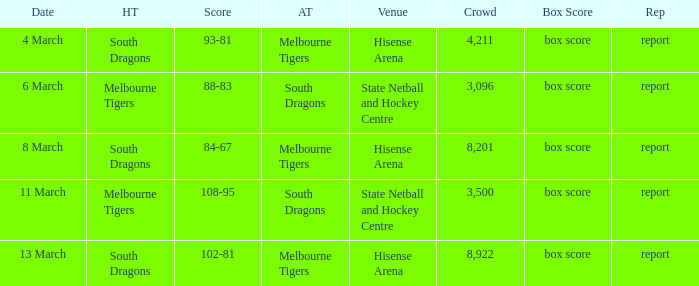Where was the venue with 3,096 in the crowd and against the Melbourne Tigers? Hisense Arena, Hisense Arena, Hisense Arena. 